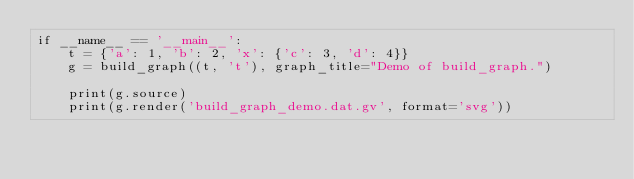<code> <loc_0><loc_0><loc_500><loc_500><_Python_>if __name__ == '__main__':
    t = {'a': 1, 'b': 2, 'x': {'c': 3, 'd': 4}}
    g = build_graph((t, 't'), graph_title="Demo of build_graph.")

    print(g.source)
    print(g.render('build_graph_demo.dat.gv', format='svg'))
</code> 